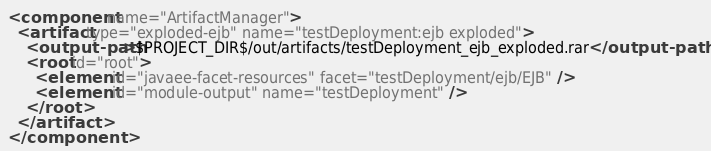Convert code to text. <code><loc_0><loc_0><loc_500><loc_500><_XML_><component name="ArtifactManager">
  <artifact type="exploded-ejb" name="testDeployment:ejb exploded">
    <output-path>$PROJECT_DIR$/out/artifacts/testDeployment_ejb_exploded.rar</output-path>
    <root id="root">
      <element id="javaee-facet-resources" facet="testDeployment/ejb/EJB" />
      <element id="module-output" name="testDeployment" />
    </root>
  </artifact>
</component></code> 